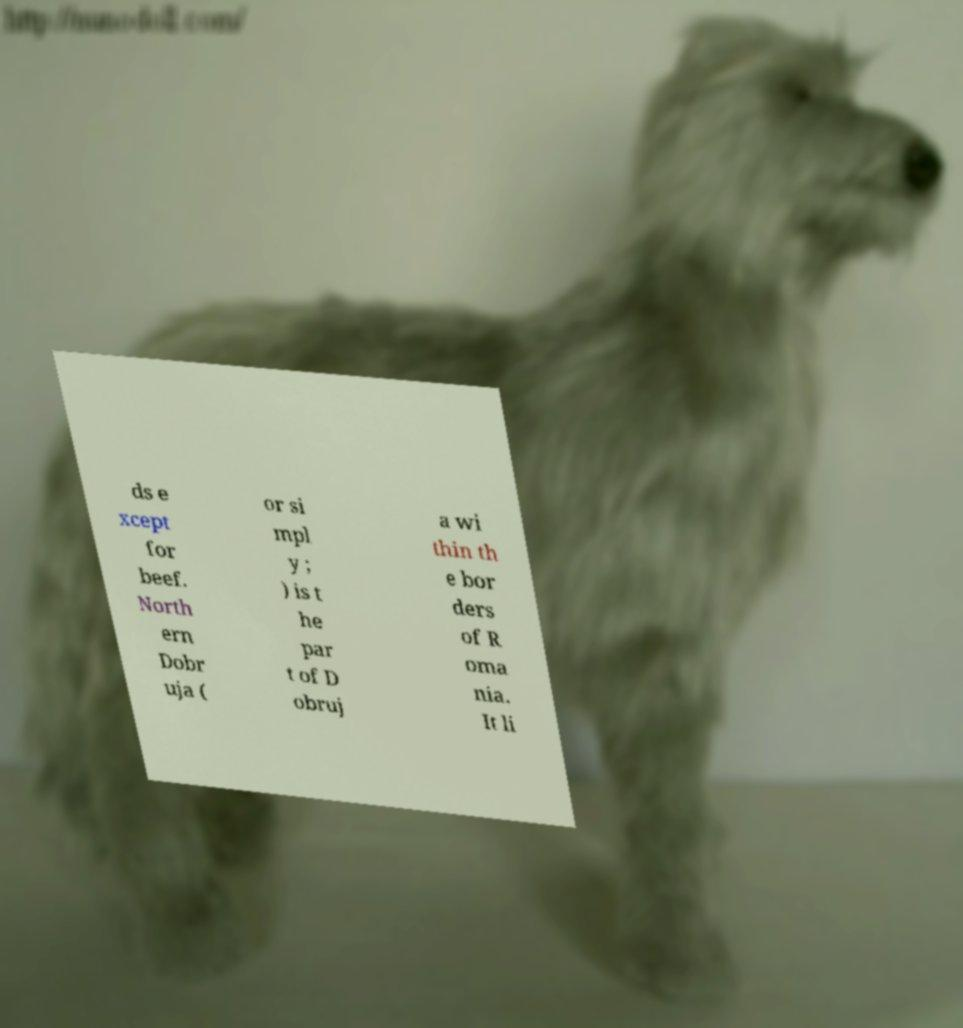For documentation purposes, I need the text within this image transcribed. Could you provide that? ds e xcept for beef. North ern Dobr uja ( or si mpl y ; ) is t he par t of D obruj a wi thin th e bor ders of R oma nia. It li 